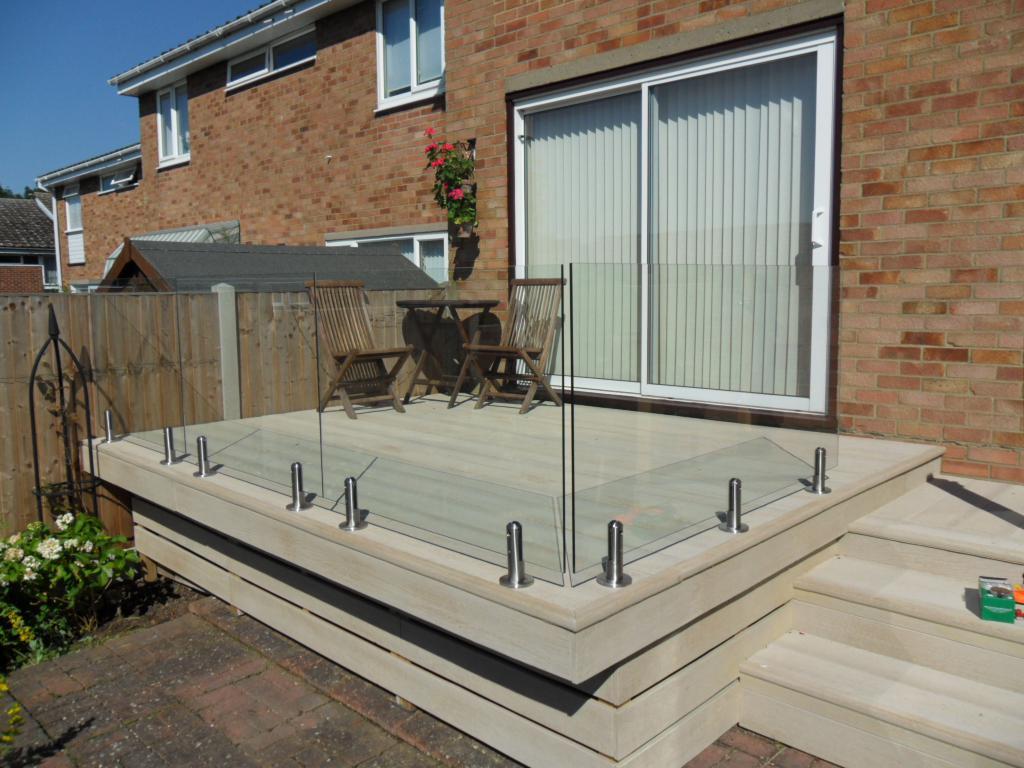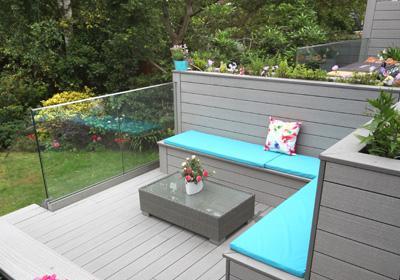The first image is the image on the left, the second image is the image on the right. For the images displayed, is the sentence "In each image, a glass-paneled balcony overlooks an area of green grass, and one of the balconies pictured has a top rail on the glass panels but the other does not." factually correct? Answer yes or no. No. The first image is the image on the left, the second image is the image on the right. For the images displayed, is the sentence "There are two chairs and one wooden slotted table on a patio that is enclosed  with glass panels." factually correct? Answer yes or no. Yes. 